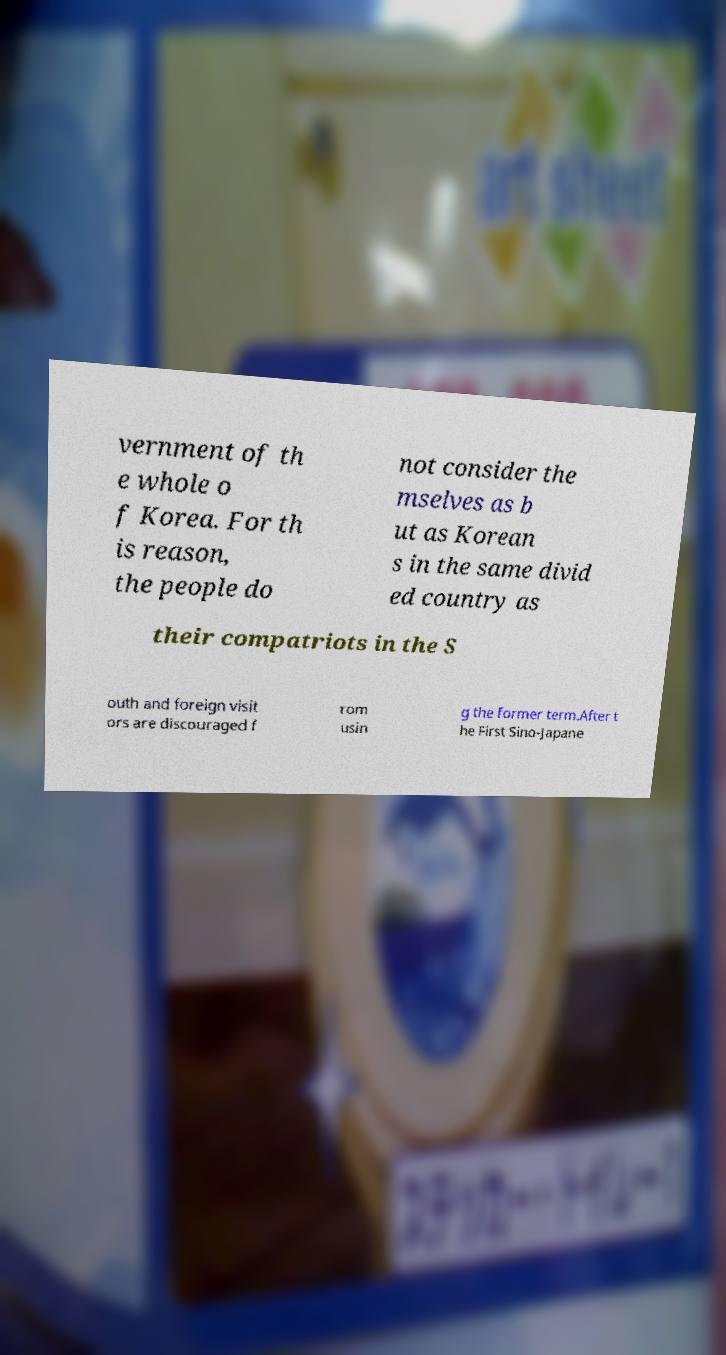Can you accurately transcribe the text from the provided image for me? vernment of th e whole o f Korea. For th is reason, the people do not consider the mselves as b ut as Korean s in the same divid ed country as their compatriots in the S outh and foreign visit ors are discouraged f rom usin g the former term.After t he First Sino-Japane 